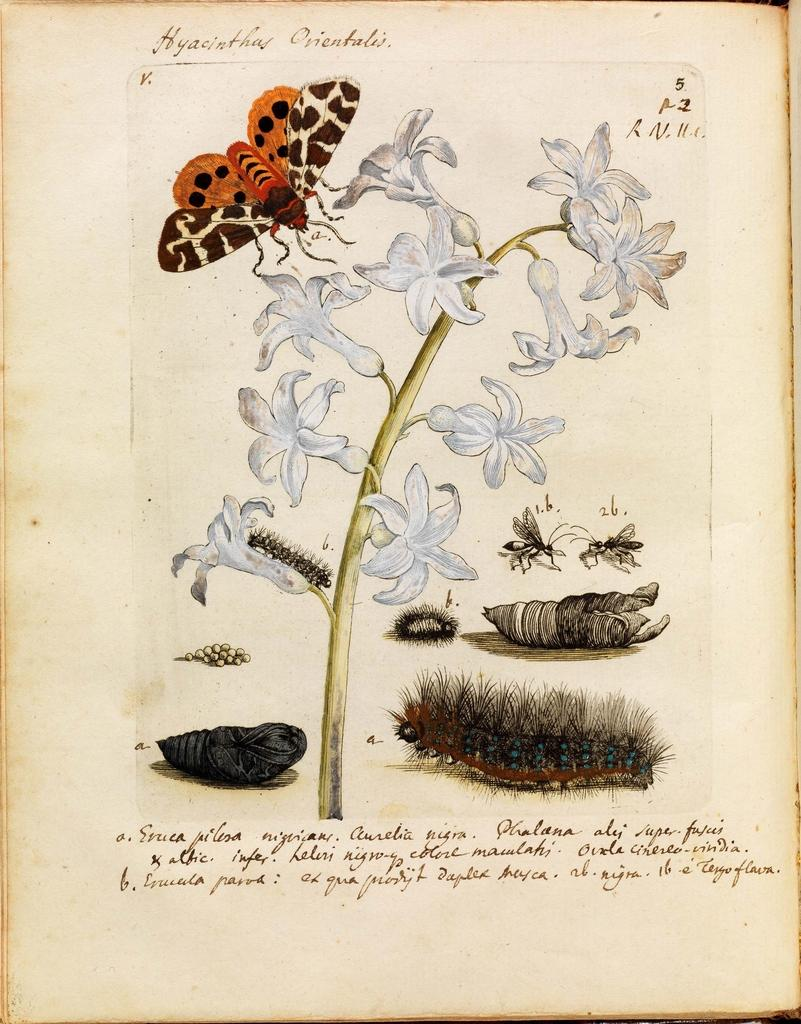What is the main subject of the image? The main subject of the image is a photo of a book page. What is depicted on the book page? The book page contains a bunch of flowers and insects. Is there any text present on the book page? Yes, there is some text on the book page. What is the condition of the cemetery in the image? There is no cemetery present in the image. How many shades of green can be seen in the image? The image is a photo of a book page, so it does not depict a natural scene with shades of green. 